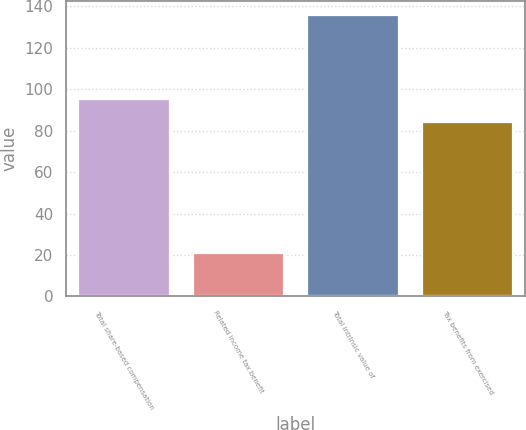<chart> <loc_0><loc_0><loc_500><loc_500><bar_chart><fcel>Total share-based compensation<fcel>Related income tax benefit<fcel>Total intrinsic value of<fcel>Tax benefits from exercised<nl><fcel>95.5<fcel>21<fcel>136<fcel>84<nl></chart> 